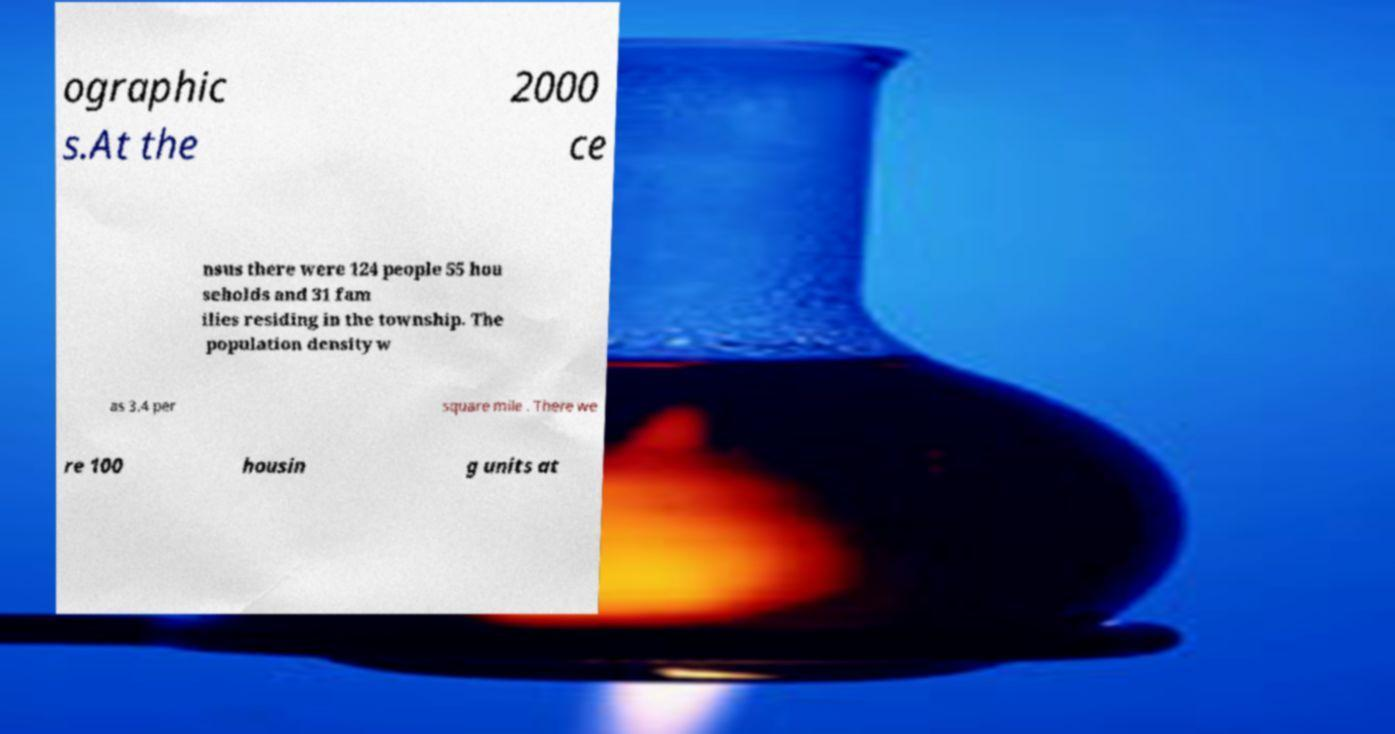Can you accurately transcribe the text from the provided image for me? ographic s.At the 2000 ce nsus there were 124 people 55 hou seholds and 31 fam ilies residing in the township. The population density w as 3.4 per square mile . There we re 100 housin g units at 